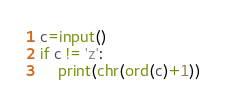<code> <loc_0><loc_0><loc_500><loc_500><_Python_>c=input()
if c != 'z':
    print(chr(ord(c)+1))</code> 